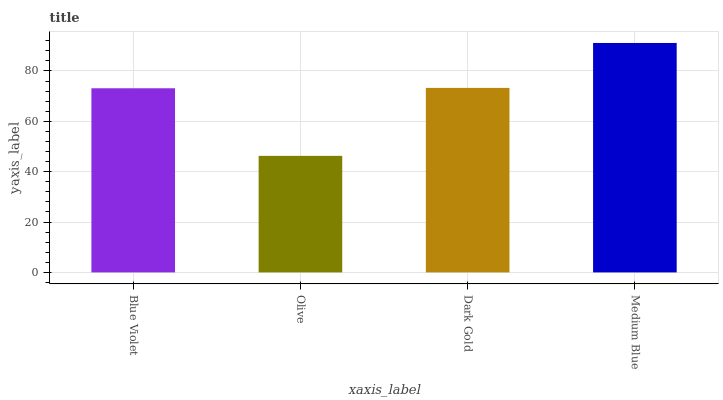Is Olive the minimum?
Answer yes or no. Yes. Is Medium Blue the maximum?
Answer yes or no. Yes. Is Dark Gold the minimum?
Answer yes or no. No. Is Dark Gold the maximum?
Answer yes or no. No. Is Dark Gold greater than Olive?
Answer yes or no. Yes. Is Olive less than Dark Gold?
Answer yes or no. Yes. Is Olive greater than Dark Gold?
Answer yes or no. No. Is Dark Gold less than Olive?
Answer yes or no. No. Is Dark Gold the high median?
Answer yes or no. Yes. Is Blue Violet the low median?
Answer yes or no. Yes. Is Olive the high median?
Answer yes or no. No. Is Olive the low median?
Answer yes or no. No. 